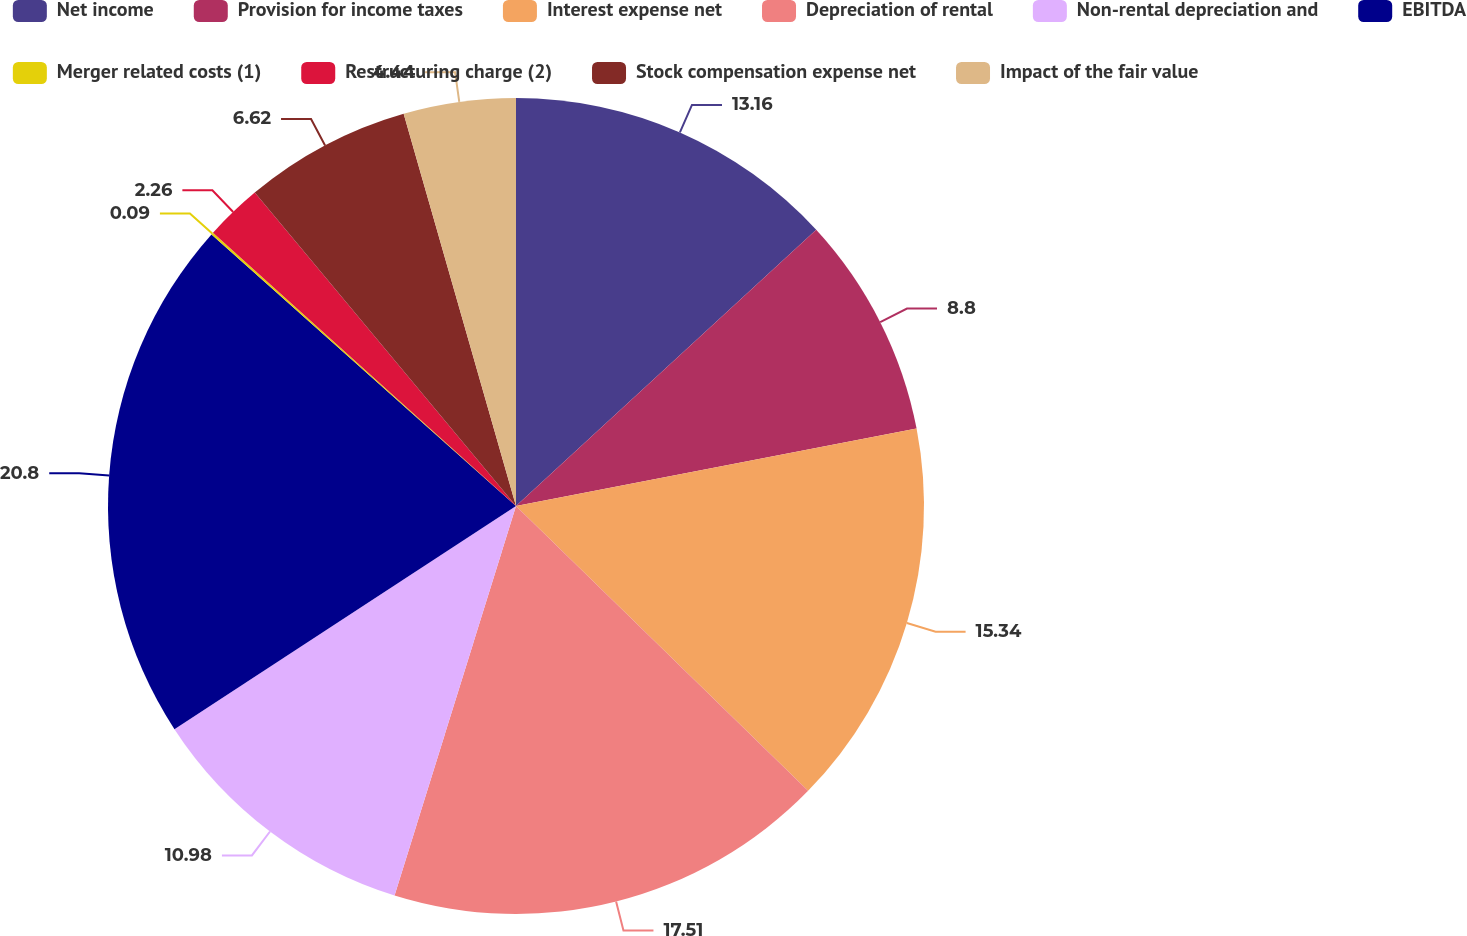<chart> <loc_0><loc_0><loc_500><loc_500><pie_chart><fcel>Net income<fcel>Provision for income taxes<fcel>Interest expense net<fcel>Depreciation of rental<fcel>Non-rental depreciation and<fcel>EBITDA<fcel>Merger related costs (1)<fcel>Restructuring charge (2)<fcel>Stock compensation expense net<fcel>Impact of the fair value<nl><fcel>13.16%<fcel>8.8%<fcel>15.34%<fcel>17.51%<fcel>10.98%<fcel>20.8%<fcel>0.09%<fcel>2.26%<fcel>6.62%<fcel>4.44%<nl></chart> 